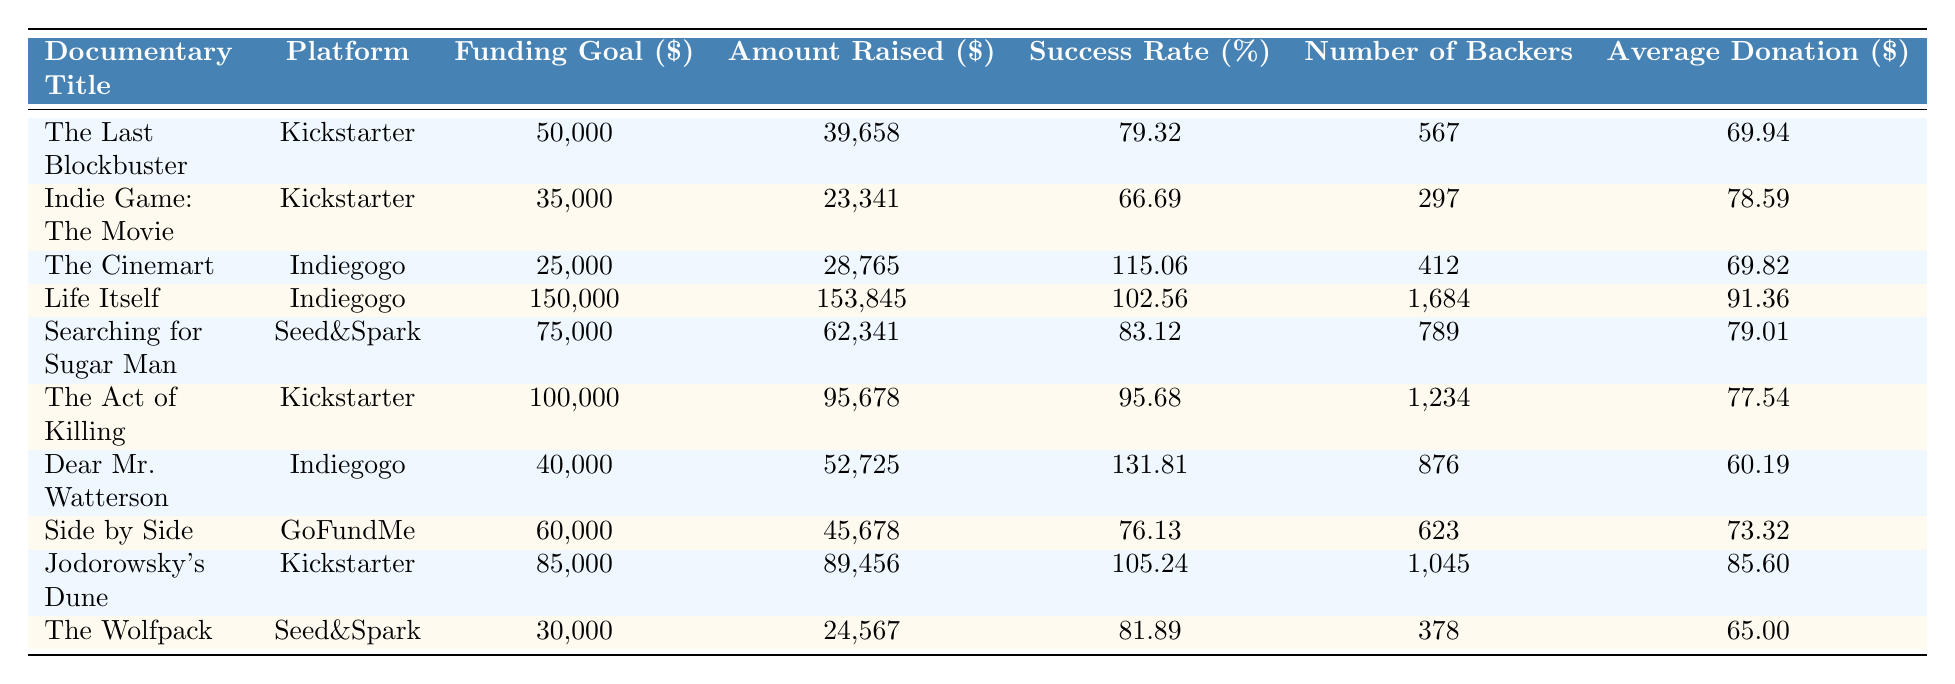What is the funding goal for "Life Itself"? The funding goal for "Life Itself" is listed under the "Funding Goal ($)" column in the table. The amount shown is 150,000.
Answer: 150,000 What platform was used for "Jodorowsky's Dune"? The platform for "Jodorowsky's Dune" can be found in the "Platform" column adjacent to the documentary title. It shows that the platform is Kickstarter.
Answer: Kickstarter Who had the highest success rate? To find the highest success rate, we can compare the values in the "Success Rate (%)" column. "Dear Mr. Watterson" has the highest success rate at 131.81%.
Answer: Dear Mr. Watterson What is the average donation for "The Act of Killing"? The average donation can be found in the "Average Donation ($)" column next to "The Act of Killing". The amount is 77.54.
Answer: 77.54 Which documentary had the lowest number of backers? By reviewing the "Number of Backers" column, we notice that "Indie Game: The Movie" has the lowest count with 297 backers.
Answer: Indie Game: The Movie How much more was raised by "Life Itself" compared to its funding goal? We subtract the "Funding Goal ($)" from the "Amount Raised ($)" for "Life Itself": 153,845 - 150,000 = 3,845.
Answer: 3,845 What is the average success rate of the documentaries listed in the table? We sum all the success rates from the "Success Rate (%)" column, which totals 679.35, and divide by the number of documentaries, which is 10, giving an average of 67.935%.
Answer: 67.935 Is "Searching for Sugar Man" more successful than "The Wolfpack" in terms of funding? We compare the "Success Rate (%)": "Searching for Sugar Man" at 83.12% is higher than "The Wolfpack" at 81.89%. Therefore, yes, it is more successful.
Answer: Yes Which platform had the highest total amount raised across all its campaigns? We need to add the amounts raised for each platform: Kickstarter (39658 + 23341 + 95678 + 89456 = 248,133), Indiegogo (28765 + 153845 + 52725 = 210,335), Seed&Spark (62341 + 24567 = 86,908), GoFundMe (45678 = 45,678). Kickstarter has the highest total amount raised at 248,133.
Answer: Kickstarter What is the difference in funding goals between the documentary with the highest funding goal and the one with the lowest? The highest funding goal is 150,000 (for "Life Itself") and the lowest is 25,000 (for "The Cinemart"). The difference is 150,000 - 25,000 = 125,000.
Answer: 125,000 